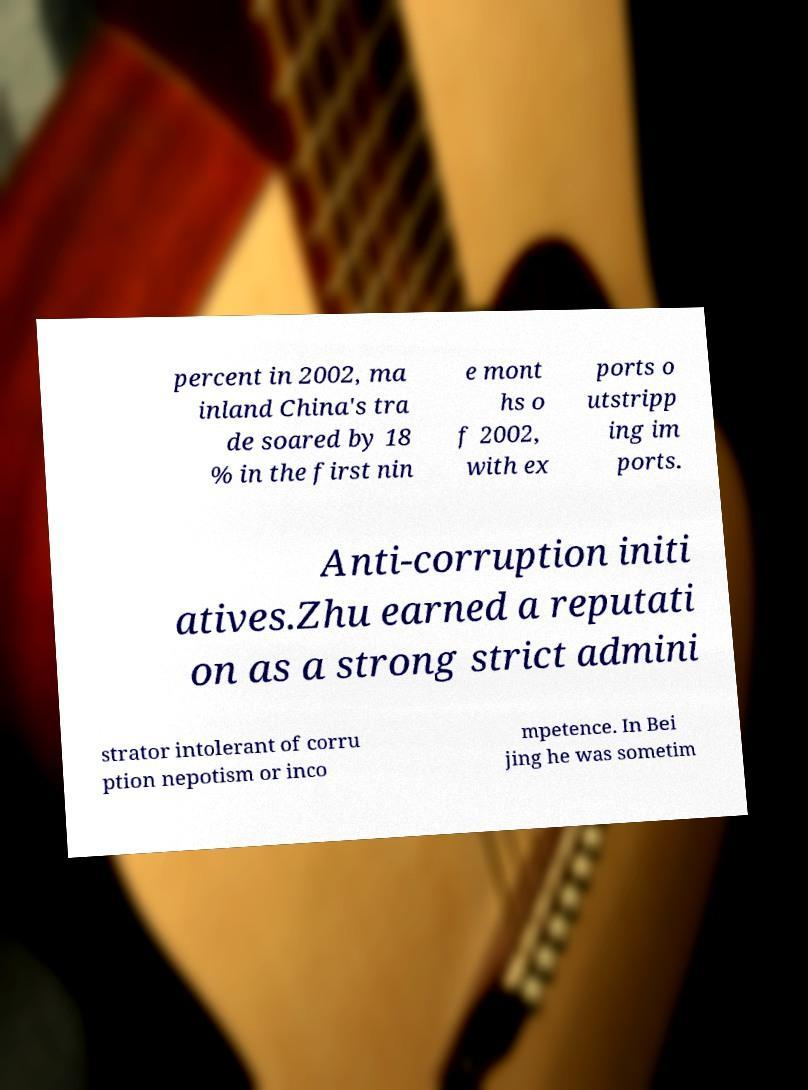For documentation purposes, I need the text within this image transcribed. Could you provide that? percent in 2002, ma inland China's tra de soared by 18 % in the first nin e mont hs o f 2002, with ex ports o utstripp ing im ports. Anti-corruption initi atives.Zhu earned a reputati on as a strong strict admini strator intolerant of corru ption nepotism or inco mpetence. In Bei jing he was sometim 